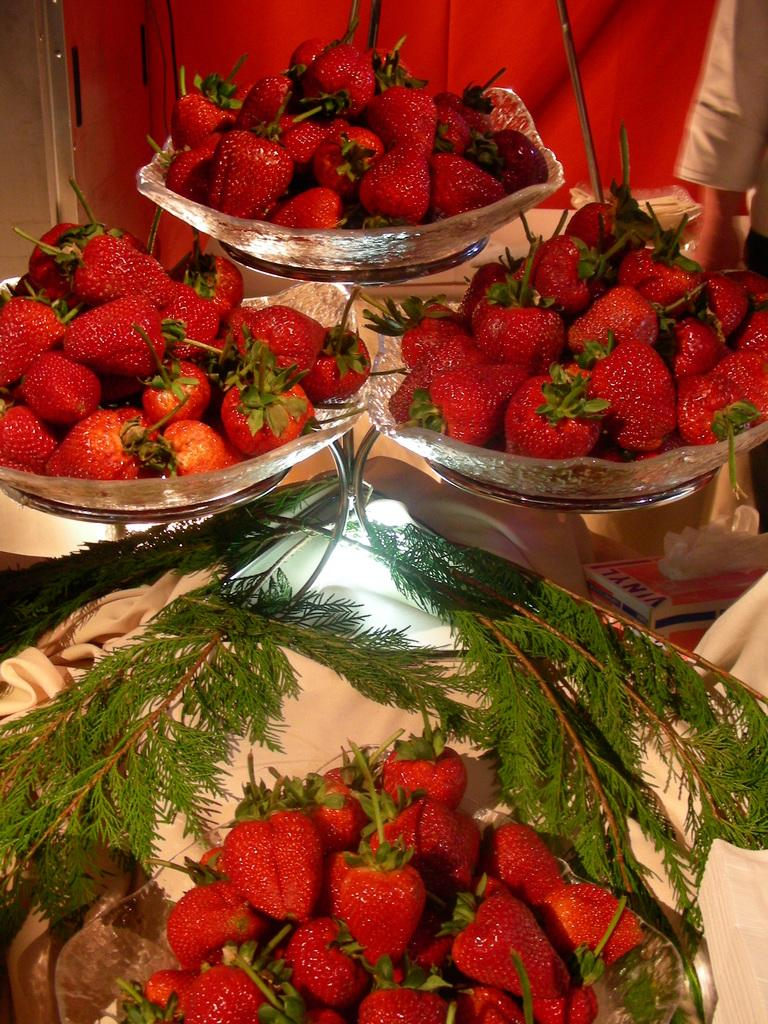What type of containers are present in the image? There are bowls in the image. What type of fruit can be seen in the image? There are strawberries in the image. What type of vegetation is visible in the image? There are green leaves in the image. Whose hand is visible in the image? A person's hand is visible in the image. What can be inferred about the objects in the image? There are objects in the image, which may include utensils or other items related to the strawberries. What is the color of the wall in the background of the image? There is a red wall in the background of the image. What type of skirt is being worn by the drain in the image? There is no skirt or drain present in the image. What type of servant can be seen attending to the person's hand in the image? There is no servant present in the image; only a person's hand is visible. 